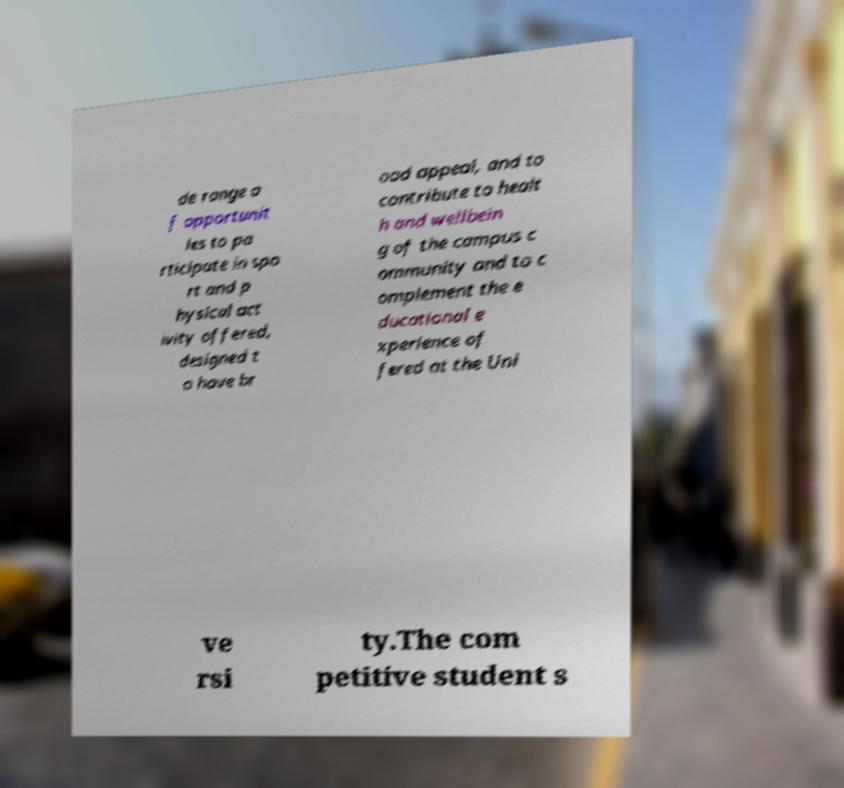Could you extract and type out the text from this image? de range o f opportunit ies to pa rticipate in spo rt and p hysical act ivity offered, designed t o have br oad appeal, and to contribute to healt h and wellbein g of the campus c ommunity and to c omplement the e ducational e xperience of fered at the Uni ve rsi ty.The com petitive student s 